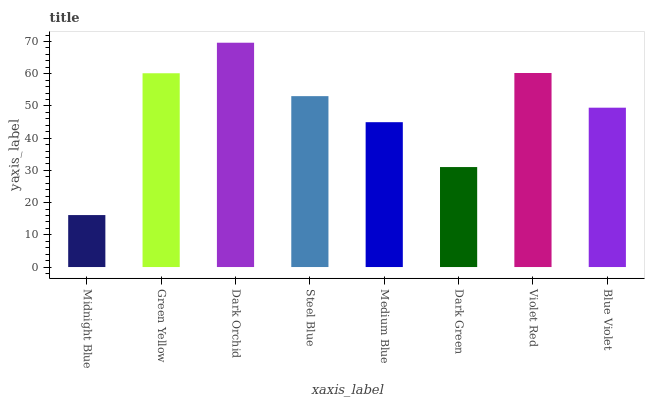Is Midnight Blue the minimum?
Answer yes or no. Yes. Is Dark Orchid the maximum?
Answer yes or no. Yes. Is Green Yellow the minimum?
Answer yes or no. No. Is Green Yellow the maximum?
Answer yes or no. No. Is Green Yellow greater than Midnight Blue?
Answer yes or no. Yes. Is Midnight Blue less than Green Yellow?
Answer yes or no. Yes. Is Midnight Blue greater than Green Yellow?
Answer yes or no. No. Is Green Yellow less than Midnight Blue?
Answer yes or no. No. Is Steel Blue the high median?
Answer yes or no. Yes. Is Blue Violet the low median?
Answer yes or no. Yes. Is Dark Orchid the high median?
Answer yes or no. No. Is Medium Blue the low median?
Answer yes or no. No. 